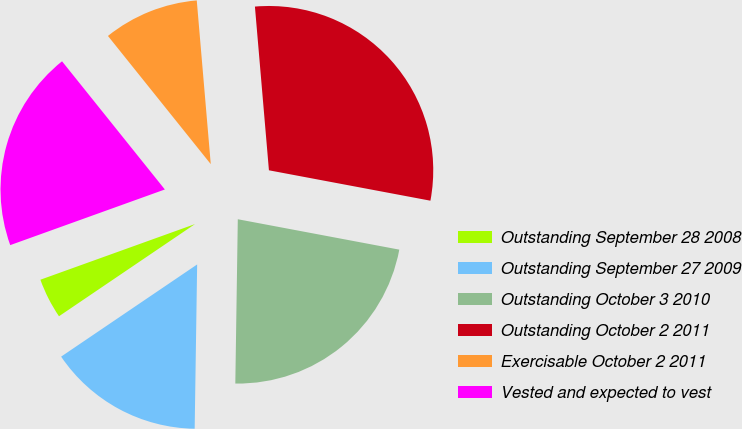<chart> <loc_0><loc_0><loc_500><loc_500><pie_chart><fcel>Outstanding September 28 2008<fcel>Outstanding September 27 2009<fcel>Outstanding October 3 2010<fcel>Outstanding October 2 2011<fcel>Exercisable October 2 2011<fcel>Vested and expected to vest<nl><fcel>3.98%<fcel>15.28%<fcel>22.28%<fcel>29.32%<fcel>9.4%<fcel>19.74%<nl></chart> 